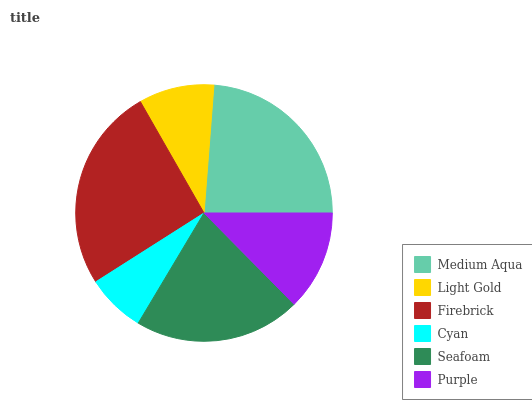Is Cyan the minimum?
Answer yes or no. Yes. Is Firebrick the maximum?
Answer yes or no. Yes. Is Light Gold the minimum?
Answer yes or no. No. Is Light Gold the maximum?
Answer yes or no. No. Is Medium Aqua greater than Light Gold?
Answer yes or no. Yes. Is Light Gold less than Medium Aqua?
Answer yes or no. Yes. Is Light Gold greater than Medium Aqua?
Answer yes or no. No. Is Medium Aqua less than Light Gold?
Answer yes or no. No. Is Seafoam the high median?
Answer yes or no. Yes. Is Purple the low median?
Answer yes or no. Yes. Is Medium Aqua the high median?
Answer yes or no. No. Is Light Gold the low median?
Answer yes or no. No. 